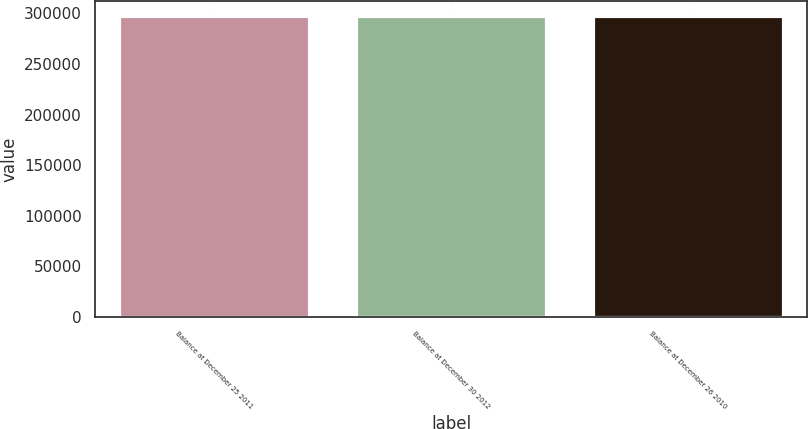<chart> <loc_0><loc_0><loc_500><loc_500><bar_chart><fcel>Balance at December 25 2011<fcel>Balance at December 30 2012<fcel>Balance at December 26 2010<nl><fcel>296978<fcel>296978<fcel>296978<nl></chart> 